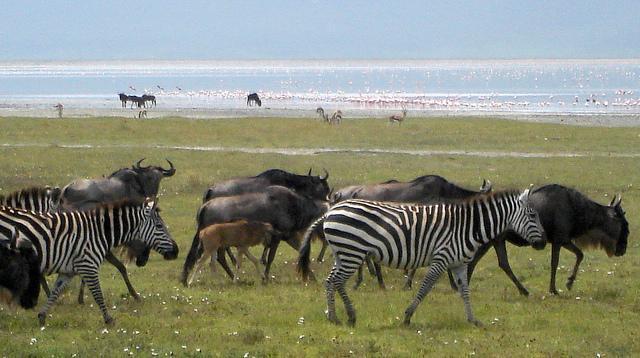How many zebras are in the photo?
Give a very brief answer. 3. How many zebras are there?
Give a very brief answer. 2. How many baby sheep are there?
Give a very brief answer. 0. 